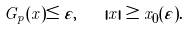Convert formula to latex. <formula><loc_0><loc_0><loc_500><loc_500>G _ { p } ( x ) \leq \varepsilon , \quad | x | \geq x _ { 0 } ( \varepsilon ) .</formula> 